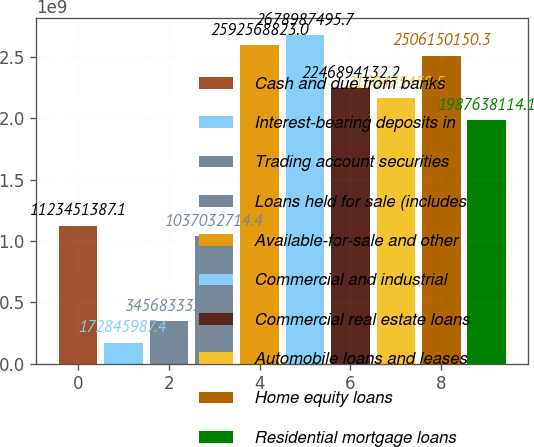Convert chart to OTSL. <chart><loc_0><loc_0><loc_500><loc_500><bar_chart><fcel>Cash and due from banks<fcel>Interest-bearing deposits in<fcel>Trading account securities<fcel>Loans held for sale (includes<fcel>Available-for-sale and other<fcel>Commercial and industrial<fcel>Commercial real estate loans<fcel>Automobile loans and leases<fcel>Home equity loans<fcel>Residential mortgage loans<nl><fcel>1.12345e+09<fcel>1.72846e+08<fcel>3.45683e+08<fcel>1.03703e+09<fcel>2.59257e+09<fcel>2.67899e+09<fcel>2.24689e+09<fcel>2.16048e+09<fcel>2.50615e+09<fcel>1.98764e+09<nl></chart> 